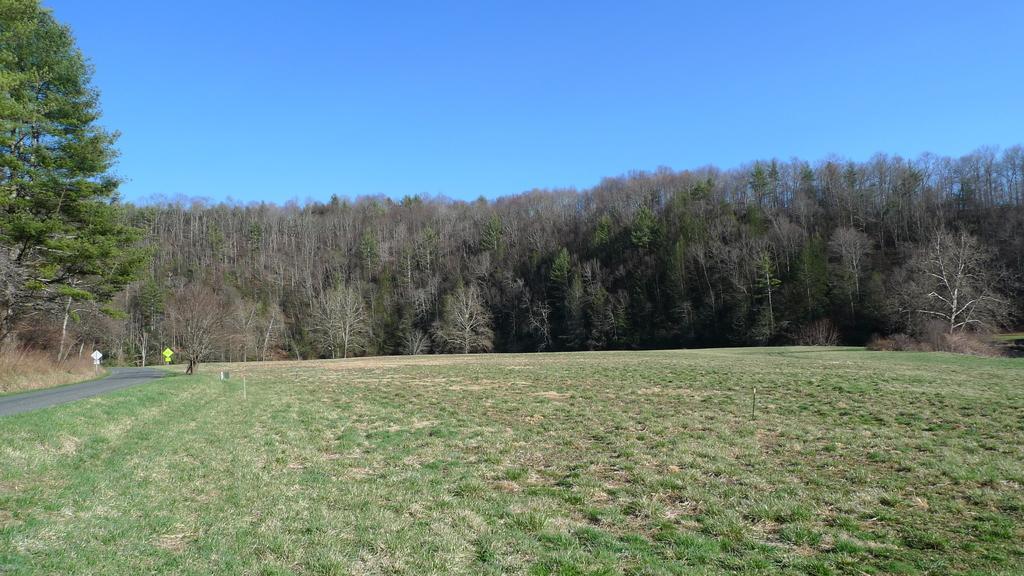How would you summarize this image in a sentence or two? In this image there is a grass on the surface. At the left side there is a road and sign boards. At the back side there are trees and at the top there is sky. 